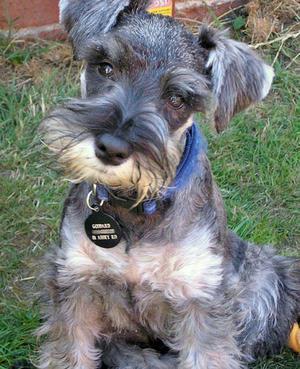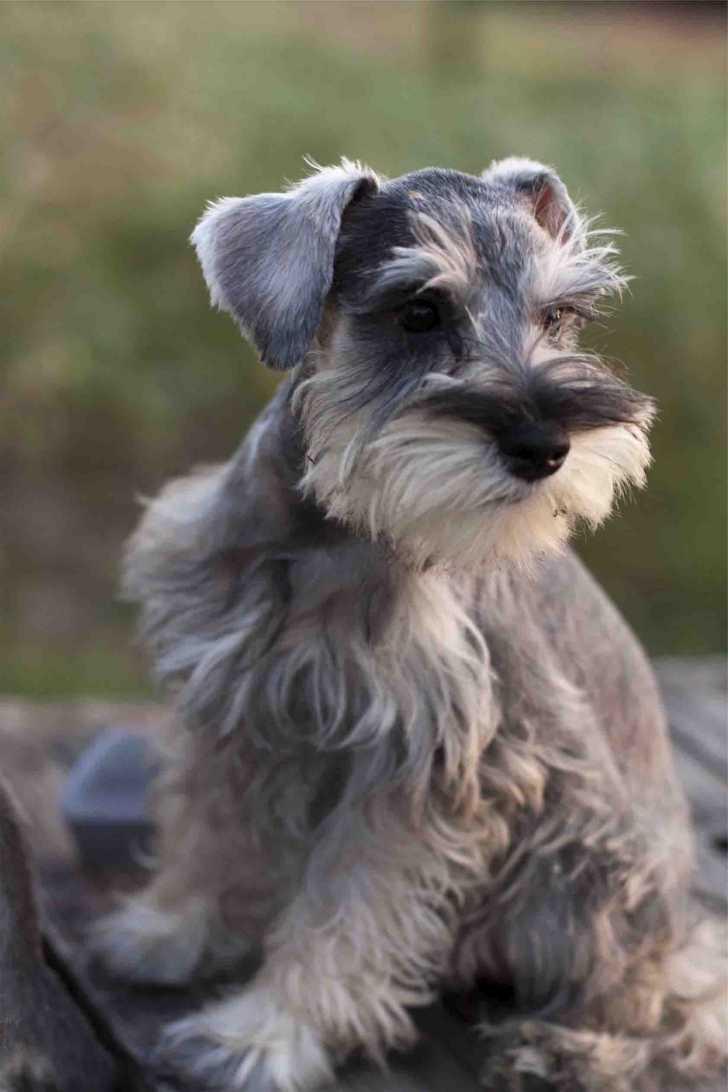The first image is the image on the left, the second image is the image on the right. Assess this claim about the two images: "There are exactly five puppies in one of the images.". Correct or not? Answer yes or no. No. 